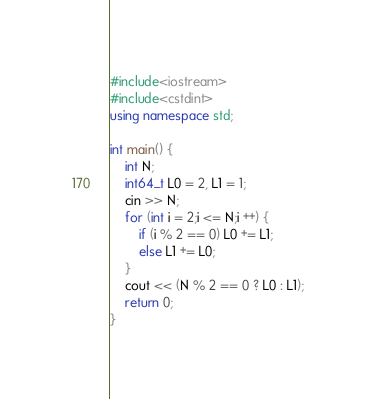<code> <loc_0><loc_0><loc_500><loc_500><_C++_>#include<iostream>
#include<cstdint>
using namespace std;

int main() {
	int N;
	int64_t L0 = 2, L1 = 1;
	cin >> N;
	for (int i = 2;i <= N;i ++) {
		if (i % 2 == 0) L0 += L1;
		else L1 += L0;
	}
	cout << (N % 2 == 0 ? L0 : L1);
	return 0;
}</code> 